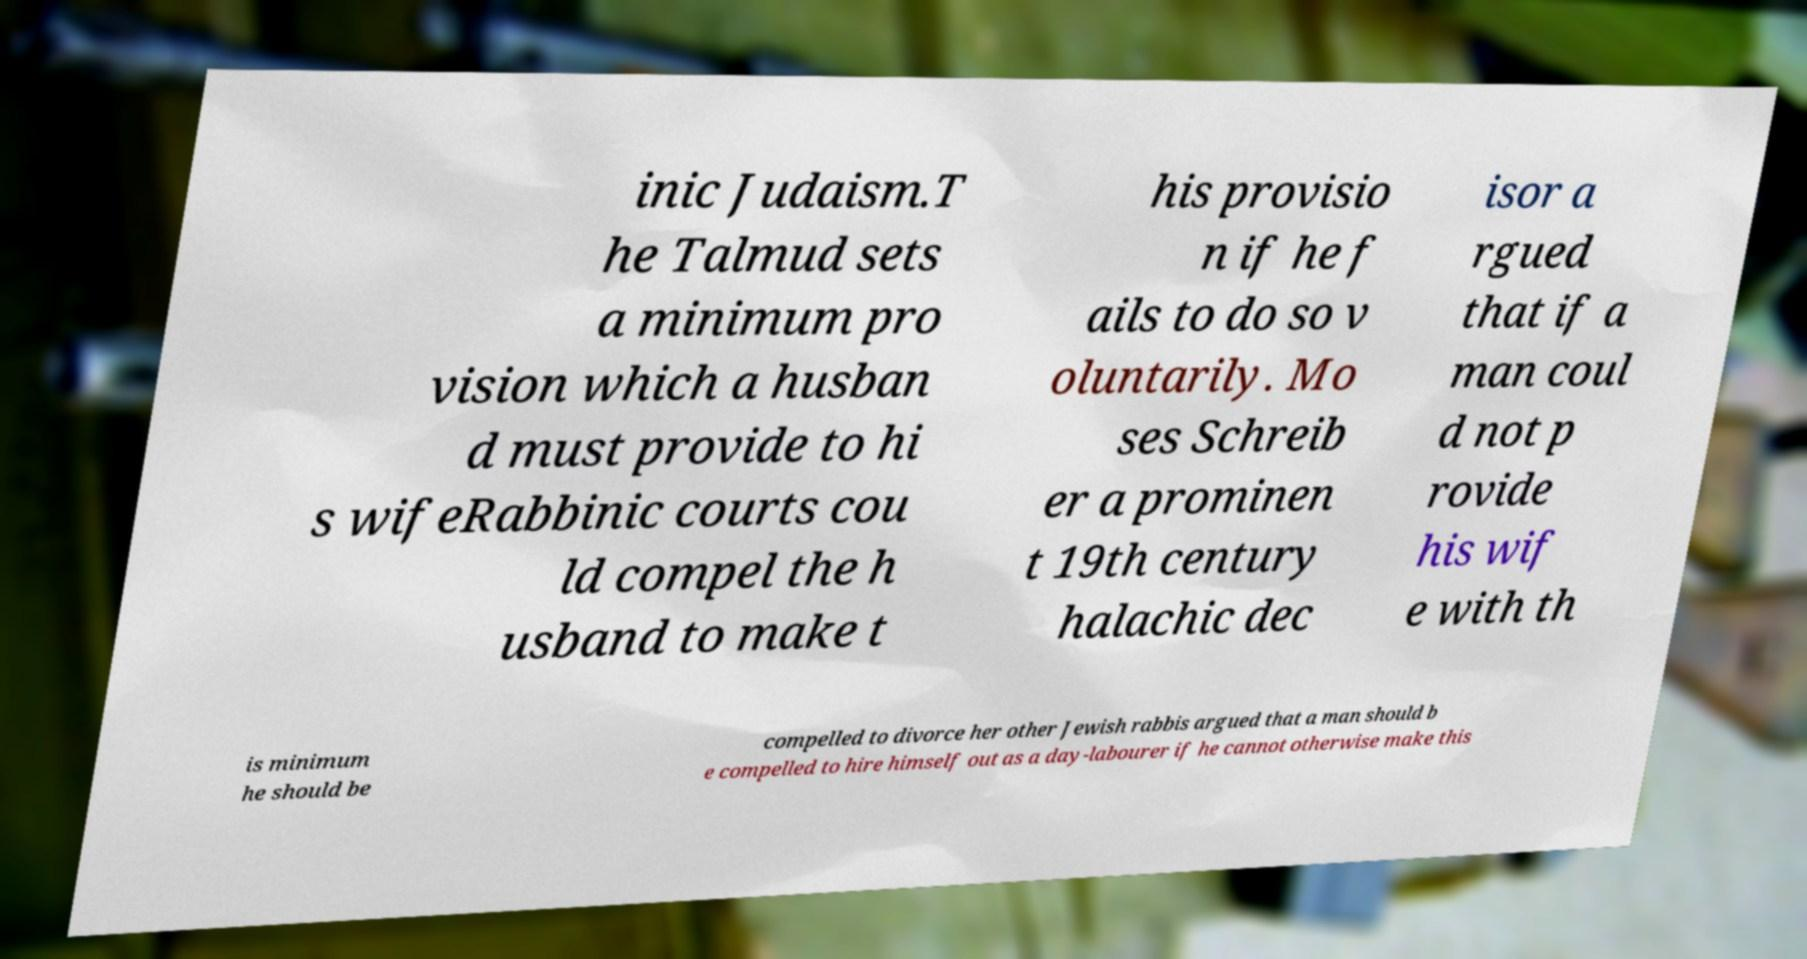What messages or text are displayed in this image? I need them in a readable, typed format. inic Judaism.T he Talmud sets a minimum pro vision which a husban d must provide to hi s wifeRabbinic courts cou ld compel the h usband to make t his provisio n if he f ails to do so v oluntarily. Mo ses Schreib er a prominen t 19th century halachic dec isor a rgued that if a man coul d not p rovide his wif e with th is minimum he should be compelled to divorce her other Jewish rabbis argued that a man should b e compelled to hire himself out as a day-labourer if he cannot otherwise make this 